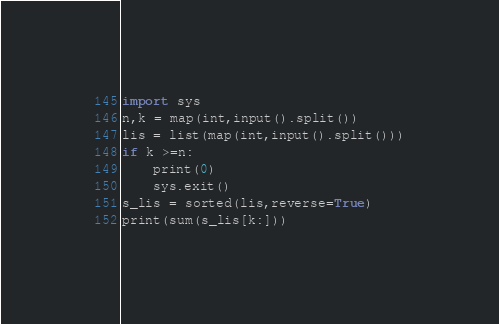<code> <loc_0><loc_0><loc_500><loc_500><_Python_>import sys
n,k = map(int,input().split())
lis = list(map(int,input().split()))
if k >=n:
    print(0)
    sys.exit()
s_lis = sorted(lis,reverse=True)
print(sum(s_lis[k:]))</code> 